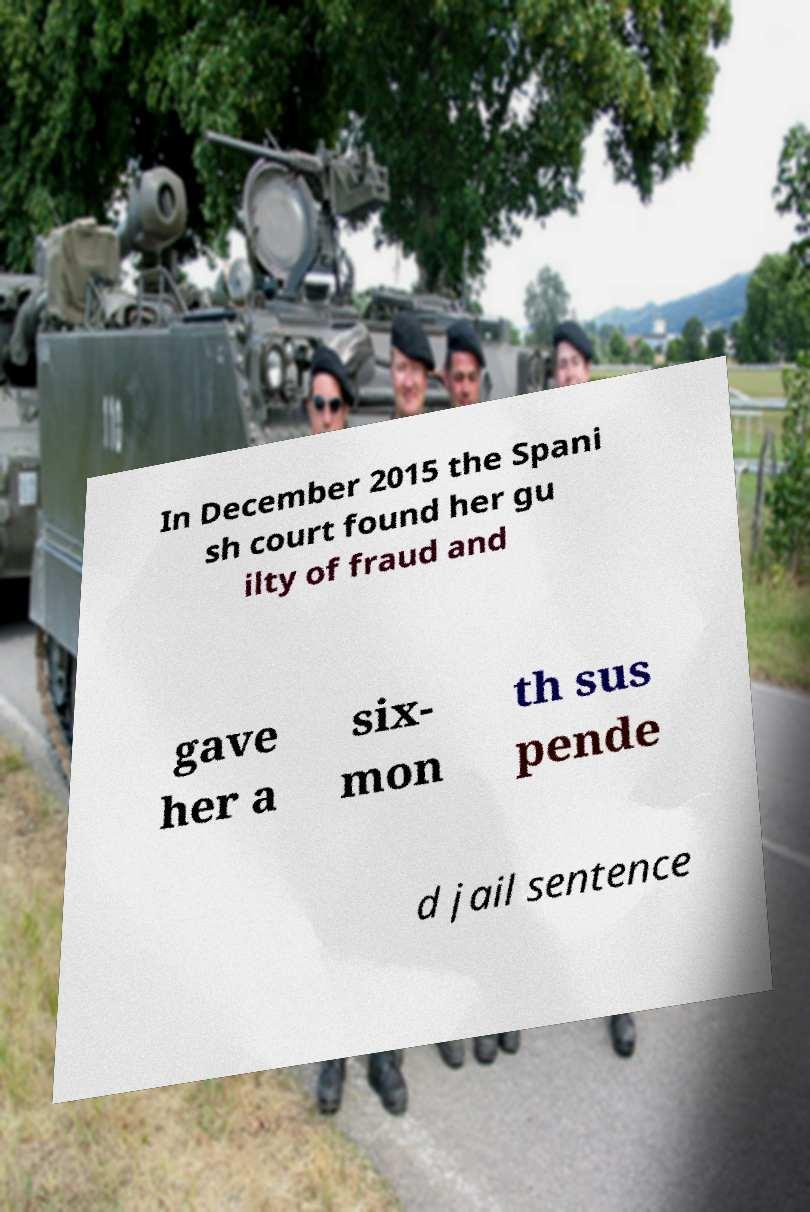Could you assist in decoding the text presented in this image and type it out clearly? In December 2015 the Spani sh court found her gu ilty of fraud and gave her a six- mon th sus pende d jail sentence 